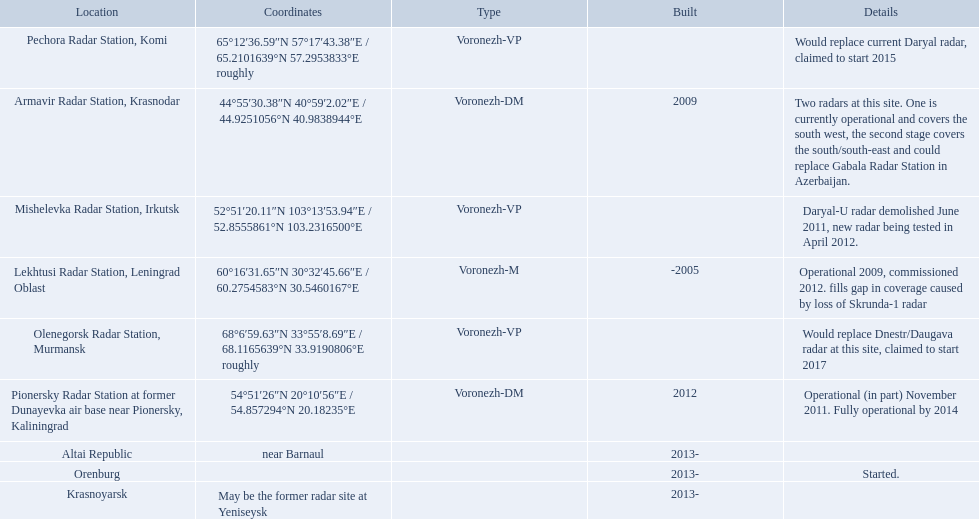Voronezh radar has locations where? Lekhtusi Radar Station, Leningrad Oblast, Armavir Radar Station, Krasnodar, Pionersky Radar Station at former Dunayevka air base near Pionersky, Kaliningrad, Mishelevka Radar Station, Irkutsk, Pechora Radar Station, Komi, Olenegorsk Radar Station, Murmansk, Krasnoyarsk, Altai Republic, Orenburg. Which of these locations have know coordinates? Lekhtusi Radar Station, Leningrad Oblast, Armavir Radar Station, Krasnodar, Pionersky Radar Station at former Dunayevka air base near Pionersky, Kaliningrad, Mishelevka Radar Station, Irkutsk, Pechora Radar Station, Komi, Olenegorsk Radar Station, Murmansk. Which of these locations has coordinates of 60deg16'31.65''n 30deg32'45.66''e / 60.2754583degn 30.5460167dege? Lekhtusi Radar Station, Leningrad Oblast. 